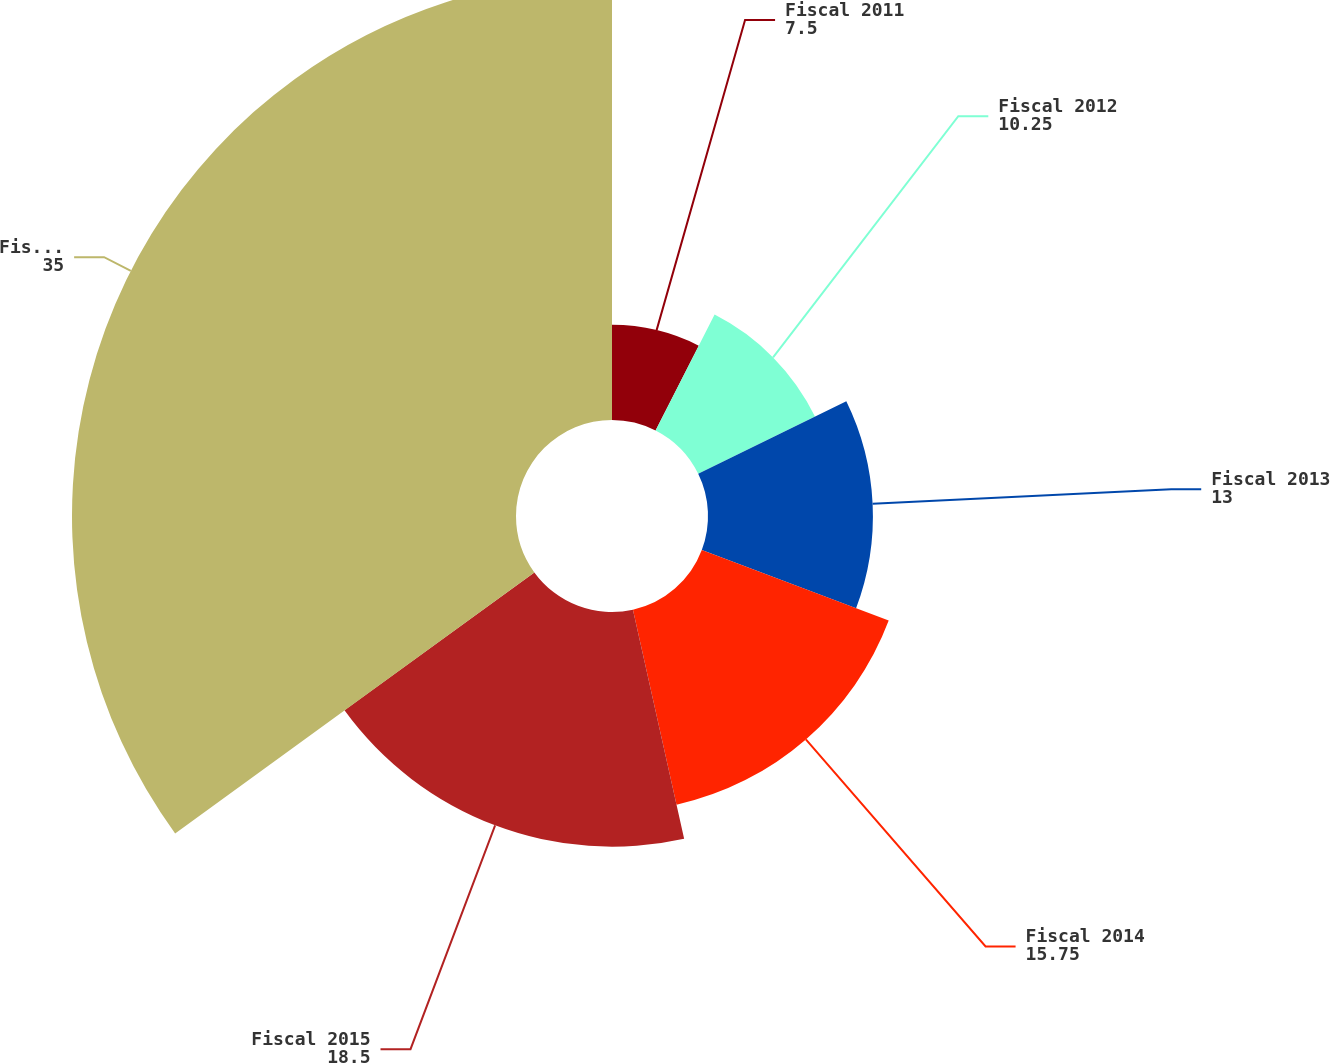<chart> <loc_0><loc_0><loc_500><loc_500><pie_chart><fcel>Fiscal 2011<fcel>Fiscal 2012<fcel>Fiscal 2013<fcel>Fiscal 2014<fcel>Fiscal 2015<fcel>Fiscal 2016-2020<nl><fcel>7.5%<fcel>10.25%<fcel>13.0%<fcel>15.75%<fcel>18.5%<fcel>35.0%<nl></chart> 